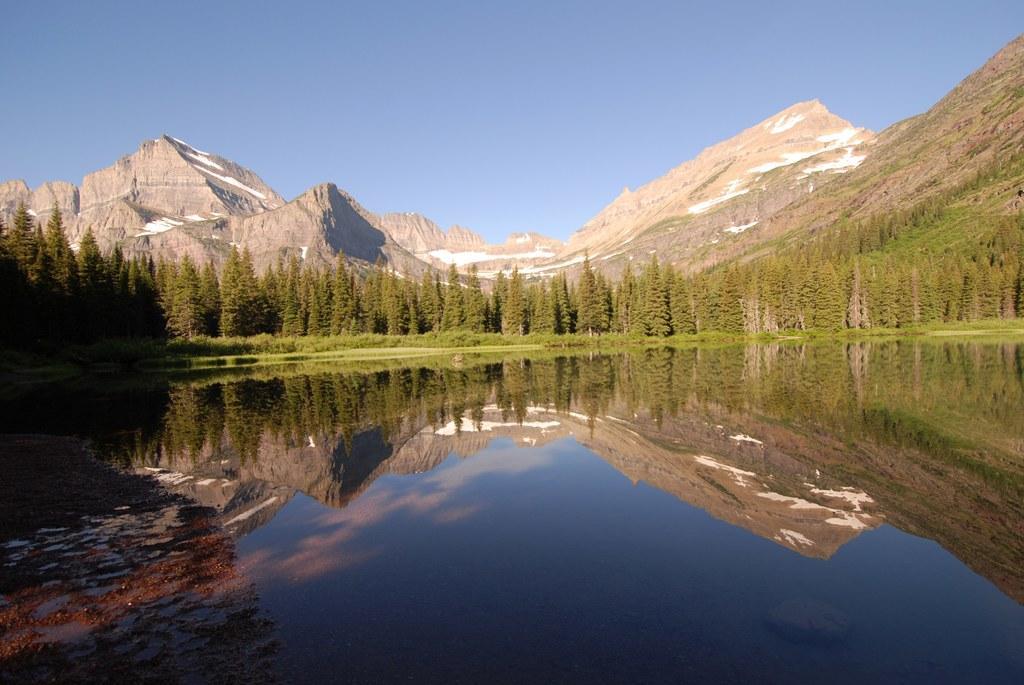Can you describe this image briefly? In this image I can see the water. To the side of the water there are many trees. In the background there are mountains and the blue sky. 